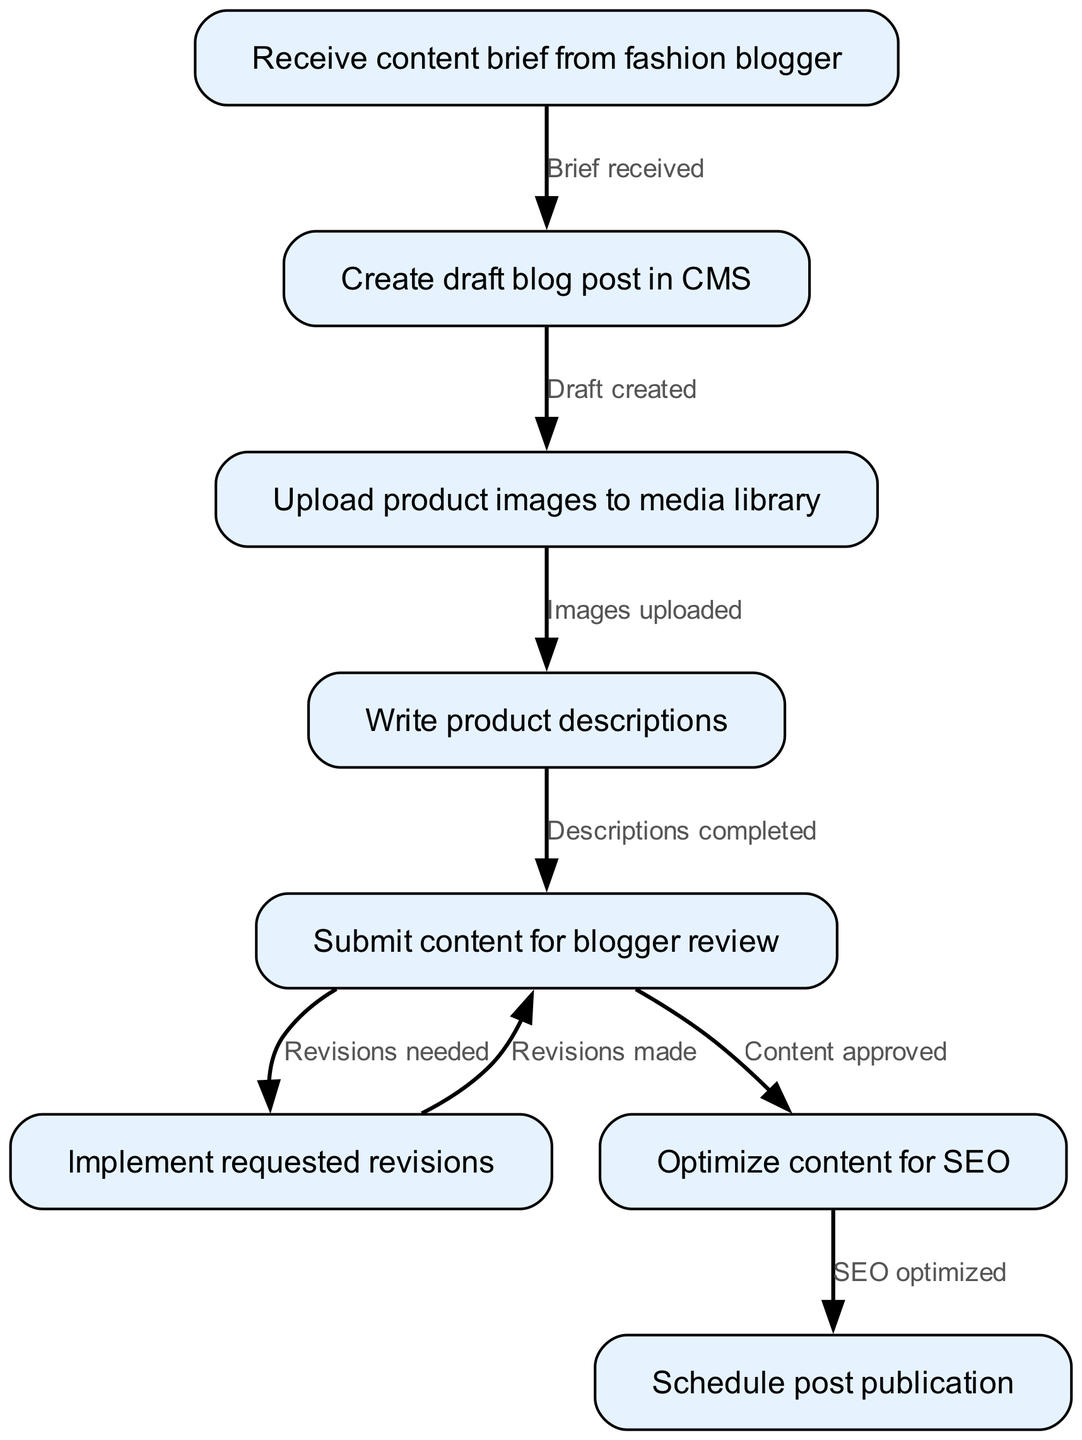What is the first step in the content creation process? The first step is receiving the content brief from the fashion blogger, represented by node "1".
Answer: Receive content brief from fashion blogger How many total nodes are in the diagram? The diagram contains a total of 8 nodes which represent steps in the content creation process.
Answer: 8 What relationship exists between drafting the blog post and uploading product images? The relationship is that after creating a draft blog post (node "2"), the next step is to upload product images to the media library (node "3"). This flow is indicated by the edge connecting these nodes.
Answer: Draft created What step follows after submitting content for blogger review? After submitting content for blogger review (node "5"), the next step is to implement requested revisions (node "6"). This is based on the directed edge leading from node "5" to node "6".
Answer: Implement requested revisions What is the last step in the process before publication? The last step before publication is scheduling the post, which is represented by node "8" that follows content optimization for SEO (node "7").
Answer: Schedule post publication Which step indicates that content has been approved? The approval of content is indicated at node "5" where it says "Content approved," which shows the transition from the review to SEO optimization.
Answer: Content approved What is the connection between writing product descriptions and submitting content for review? The connection is that after writing product descriptions (node "4"), the next action is to submit content for blogger review (node "5"). This is depicted by the edge leading from node "4" to "5".
Answer: Descriptions completed How many edges are present in the diagram? The diagram contains 7 edges that represent the relationships and flow between the various steps in the content creation process.
Answer: 7 What step occurs immediately after optimizing content for SEO? Immediately after optimizing content for SEO (node "7"), the next step is to schedule post publication (node "8"). This transition is shown by the edge connecting nodes "7" and "8".
Answer: Schedule post publication 